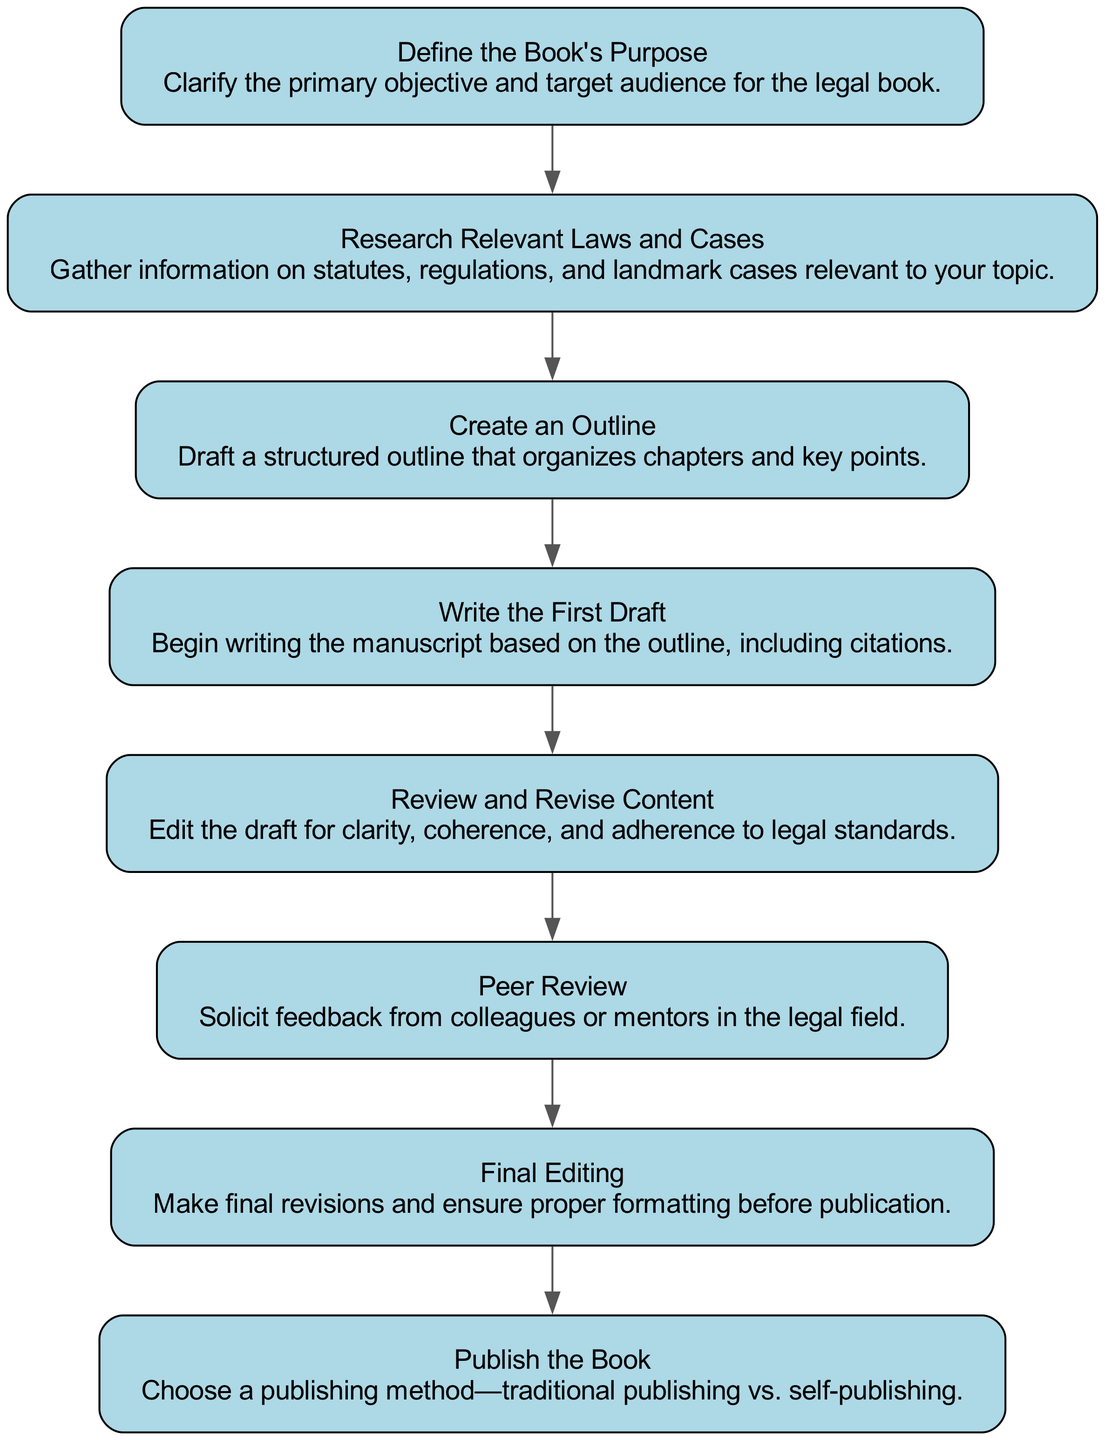What is the first step in writing a legal book? The first step is defined as "Define the Book's Purpose," which clarifies the primary objective and target audience for the legal book.
Answer: Define the Book's Purpose How many steps are involved in the process? There are eight distinct steps outlined in the flow chart for writing and editing a legal book.
Answer: Eight What is the final step before publication? The final step before publication is "Final Editing," which involves making revisions and ensuring proper formatting before the book is published.
Answer: Final Editing What comes after "Review and Revise Content"? The step that follows "Review and Revise Content" is "Peer Review," where feedback is solicited from colleagues or mentors in the legal field.
Answer: Peer Review Which step directly leads to publishing the book? The step that leads directly to publishing the book is "Final Editing," which ensures that the manuscript is ready and formatted correctly for publication.
Answer: Final Editing What are the alternatives in the last step? The alternatives in the last step, which is "Publish the Book," are traditional publishing and self-publishing.
Answer: Traditional publishing vs. self-publishing What is the main focus of the second step? The second step, "Research Relevant Laws and Cases," focuses on gathering information such as statutes, regulations, and landmark cases relevant to the book's topic.
Answer: Research Relevant Laws and Cases How is the outline created in the process? The outline is created in the third step called "Create an Outline," where a structured outline that organizes chapters and key points is drafted.
Answer: Create an Outline 